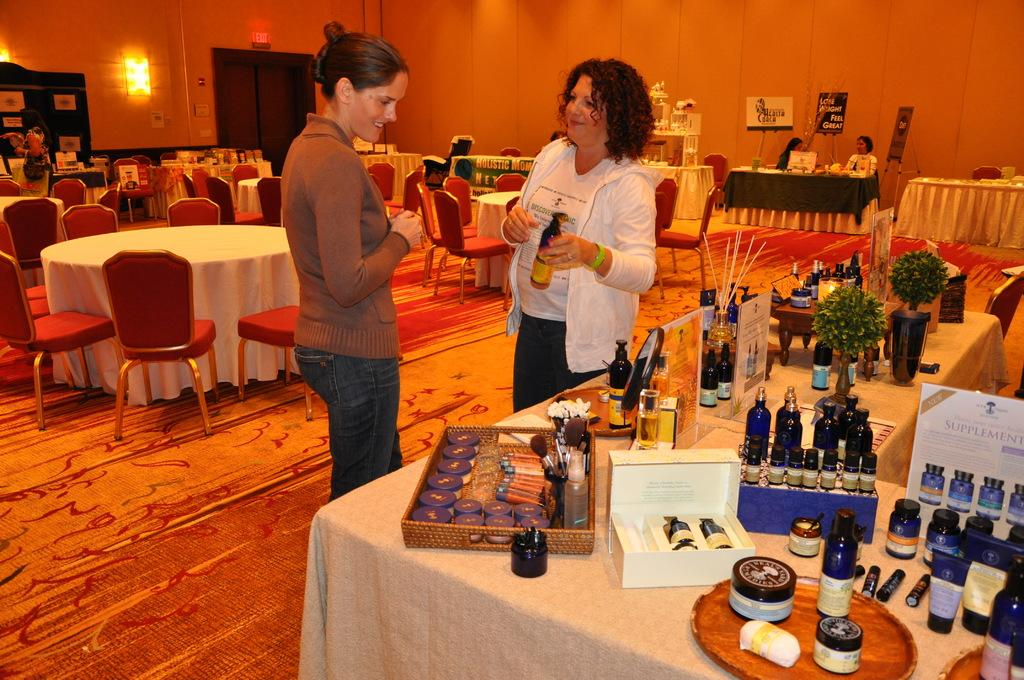How many people are present in the image? There are two people in the image. What are the people doing in the image? The people are standing beside a table. What can be seen on the table in the image? There are bottles and other things on the table. What type of furniture is present in the image? There are chairs and tables in the image. What type of finger can be seen pointing at the ducks in the image? There are no ducks or fingers pointing at them in the image. What book is the person reading in the image? There is no person reading a book in the image. 